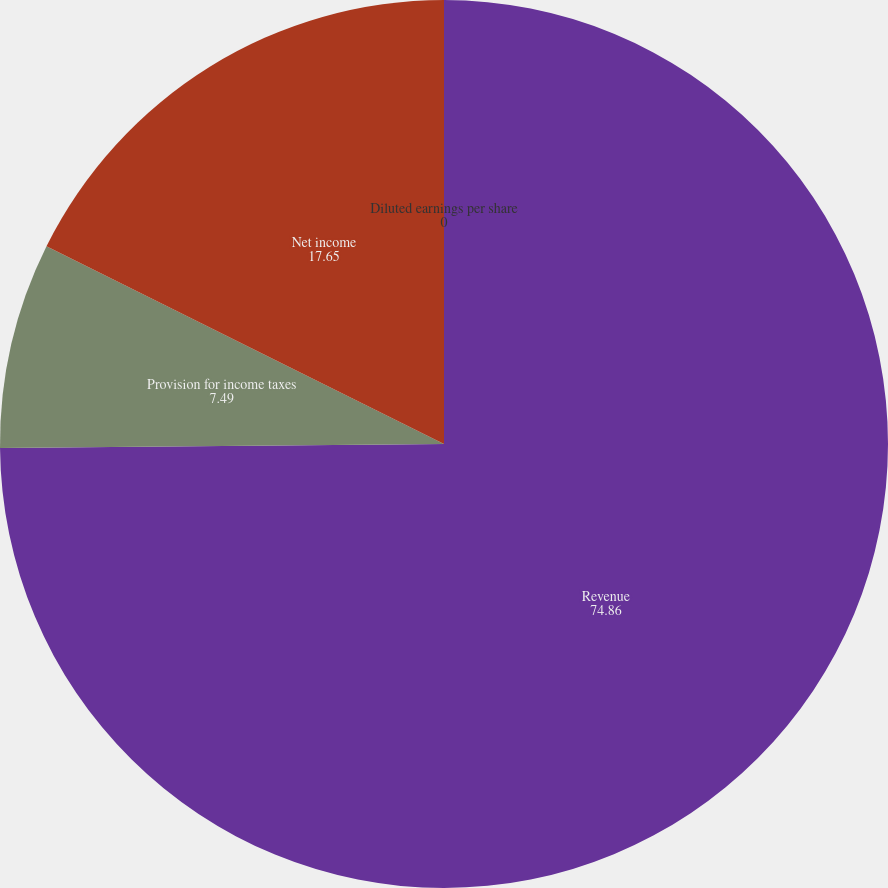Convert chart to OTSL. <chart><loc_0><loc_0><loc_500><loc_500><pie_chart><fcel>Revenue<fcel>Provision for income taxes<fcel>Net income<fcel>Diluted earnings per share<nl><fcel>74.86%<fcel>7.49%<fcel>17.65%<fcel>0.0%<nl></chart> 